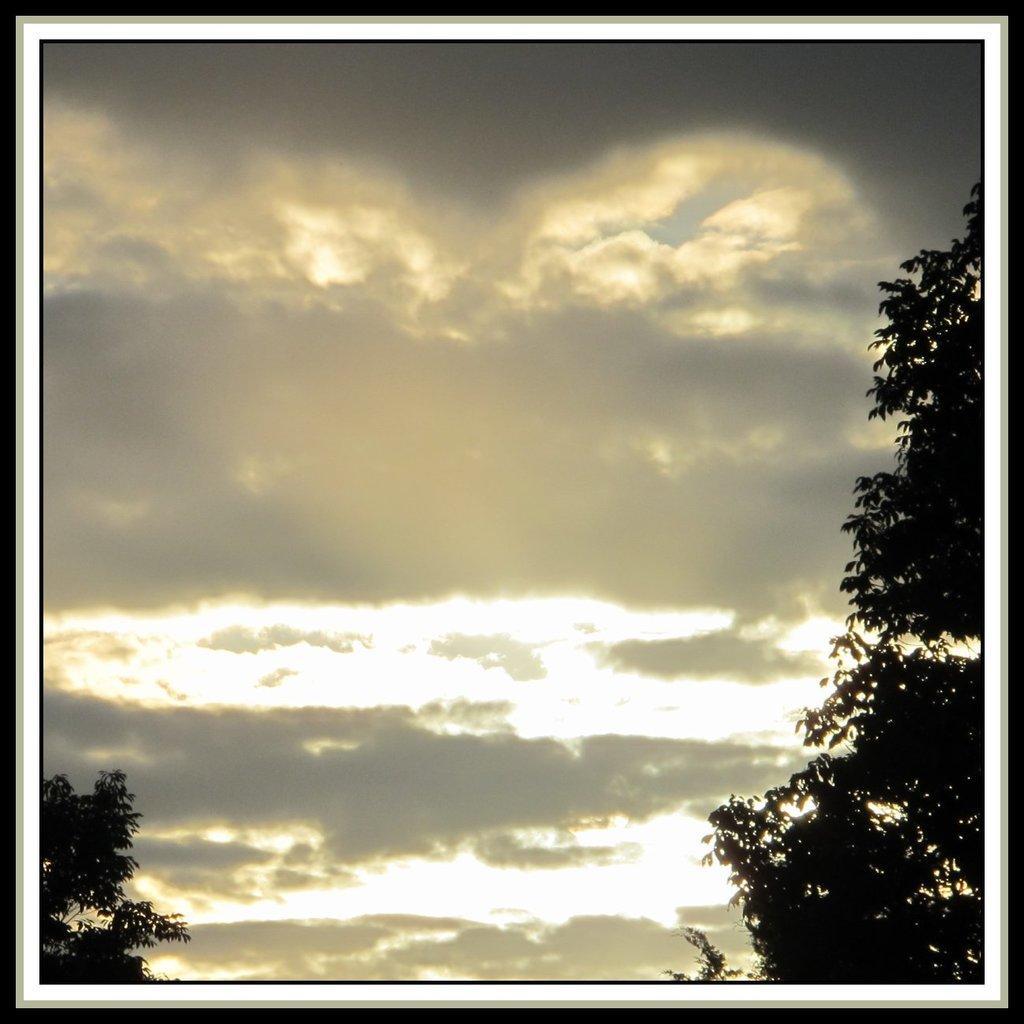Can you describe this image briefly? This is an edited image. There are trees and the sky. 